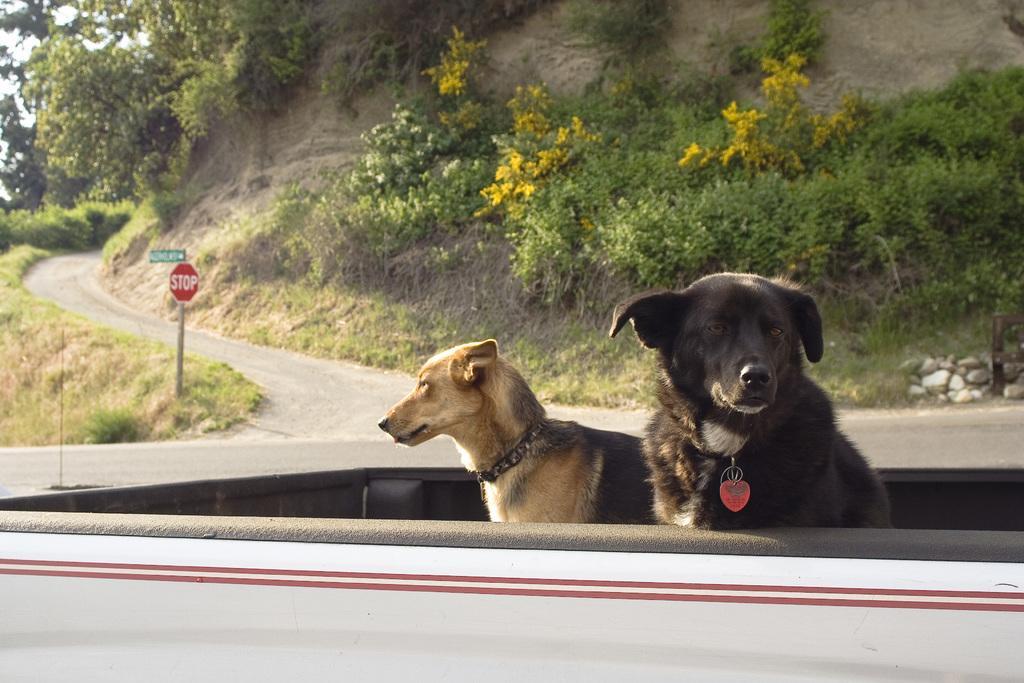How would you summarize this image in a sentence or two? In the center of the image we can see dogs in the vehicle. In the background there are trees. On the left there is a sign board and we can see a road. 